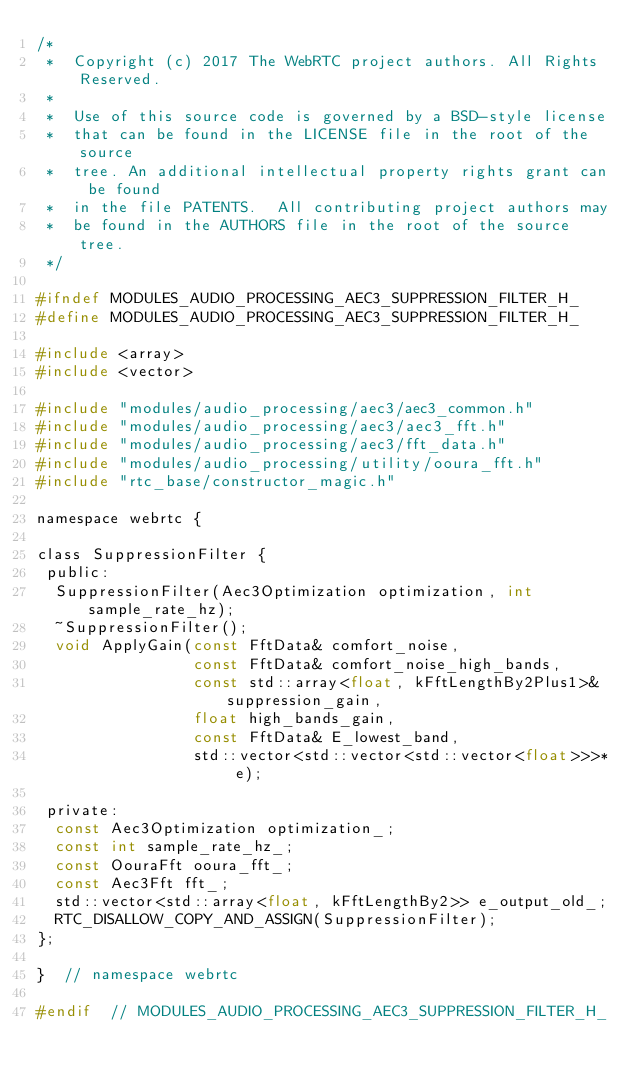Convert code to text. <code><loc_0><loc_0><loc_500><loc_500><_C_>/*
 *  Copyright (c) 2017 The WebRTC project authors. All Rights Reserved.
 *
 *  Use of this source code is governed by a BSD-style license
 *  that can be found in the LICENSE file in the root of the source
 *  tree. An additional intellectual property rights grant can be found
 *  in the file PATENTS.  All contributing project authors may
 *  be found in the AUTHORS file in the root of the source tree.
 */

#ifndef MODULES_AUDIO_PROCESSING_AEC3_SUPPRESSION_FILTER_H_
#define MODULES_AUDIO_PROCESSING_AEC3_SUPPRESSION_FILTER_H_

#include <array>
#include <vector>

#include "modules/audio_processing/aec3/aec3_common.h"
#include "modules/audio_processing/aec3/aec3_fft.h"
#include "modules/audio_processing/aec3/fft_data.h"
#include "modules/audio_processing/utility/ooura_fft.h"
#include "rtc_base/constructor_magic.h"

namespace webrtc {

class SuppressionFilter {
 public:
  SuppressionFilter(Aec3Optimization optimization, int sample_rate_hz);
  ~SuppressionFilter();
  void ApplyGain(const FftData& comfort_noise,
                 const FftData& comfort_noise_high_bands,
                 const std::array<float, kFftLengthBy2Plus1>& suppression_gain,
                 float high_bands_gain,
                 const FftData& E_lowest_band,
                 std::vector<std::vector<std::vector<float>>>* e);

 private:
  const Aec3Optimization optimization_;
  const int sample_rate_hz_;
  const OouraFft ooura_fft_;
  const Aec3Fft fft_;
  std::vector<std::array<float, kFftLengthBy2>> e_output_old_;
  RTC_DISALLOW_COPY_AND_ASSIGN(SuppressionFilter);
};

}  // namespace webrtc

#endif  // MODULES_AUDIO_PROCESSING_AEC3_SUPPRESSION_FILTER_H_
</code> 